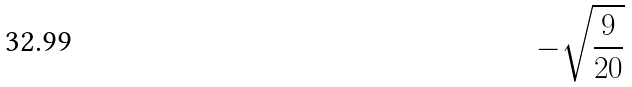Convert formula to latex. <formula><loc_0><loc_0><loc_500><loc_500>- \sqrt { \frac { 9 } { 2 0 } }</formula> 